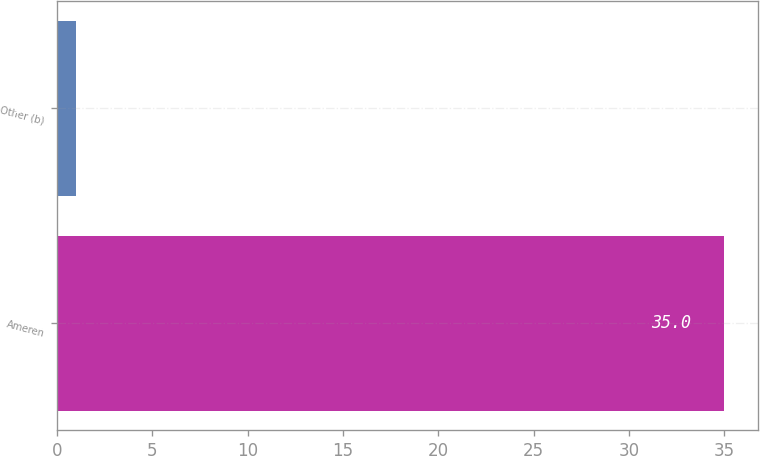Convert chart. <chart><loc_0><loc_0><loc_500><loc_500><bar_chart><fcel>Ameren<fcel>Other (b)<nl><fcel>35<fcel>1<nl></chart> 